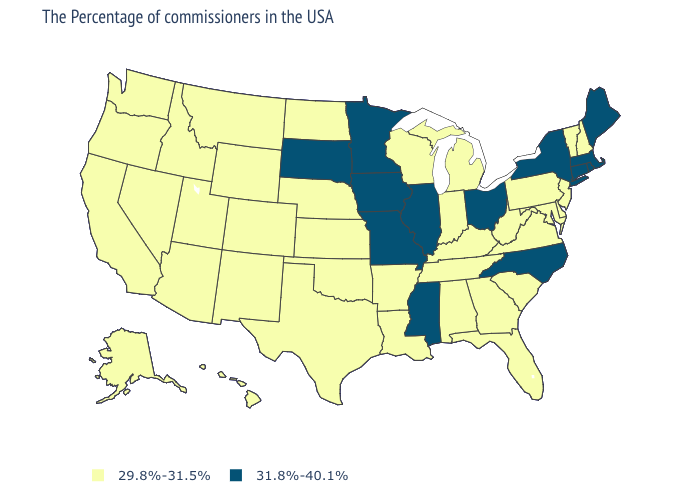Name the states that have a value in the range 31.8%-40.1%?
Write a very short answer. Maine, Massachusetts, Rhode Island, Connecticut, New York, North Carolina, Ohio, Illinois, Mississippi, Missouri, Minnesota, Iowa, South Dakota. Does the map have missing data?
Answer briefly. No. Name the states that have a value in the range 29.8%-31.5%?
Be succinct. New Hampshire, Vermont, New Jersey, Delaware, Maryland, Pennsylvania, Virginia, South Carolina, West Virginia, Florida, Georgia, Michigan, Kentucky, Indiana, Alabama, Tennessee, Wisconsin, Louisiana, Arkansas, Kansas, Nebraska, Oklahoma, Texas, North Dakota, Wyoming, Colorado, New Mexico, Utah, Montana, Arizona, Idaho, Nevada, California, Washington, Oregon, Alaska, Hawaii. Name the states that have a value in the range 29.8%-31.5%?
Be succinct. New Hampshire, Vermont, New Jersey, Delaware, Maryland, Pennsylvania, Virginia, South Carolina, West Virginia, Florida, Georgia, Michigan, Kentucky, Indiana, Alabama, Tennessee, Wisconsin, Louisiana, Arkansas, Kansas, Nebraska, Oklahoma, Texas, North Dakota, Wyoming, Colorado, New Mexico, Utah, Montana, Arizona, Idaho, Nevada, California, Washington, Oregon, Alaska, Hawaii. What is the highest value in the USA?
Concise answer only. 31.8%-40.1%. Name the states that have a value in the range 29.8%-31.5%?
Quick response, please. New Hampshire, Vermont, New Jersey, Delaware, Maryland, Pennsylvania, Virginia, South Carolina, West Virginia, Florida, Georgia, Michigan, Kentucky, Indiana, Alabama, Tennessee, Wisconsin, Louisiana, Arkansas, Kansas, Nebraska, Oklahoma, Texas, North Dakota, Wyoming, Colorado, New Mexico, Utah, Montana, Arizona, Idaho, Nevada, California, Washington, Oregon, Alaska, Hawaii. Does Nebraska have a higher value than Rhode Island?
Quick response, please. No. Name the states that have a value in the range 31.8%-40.1%?
Keep it brief. Maine, Massachusetts, Rhode Island, Connecticut, New York, North Carolina, Ohio, Illinois, Mississippi, Missouri, Minnesota, Iowa, South Dakota. Name the states that have a value in the range 31.8%-40.1%?
Keep it brief. Maine, Massachusetts, Rhode Island, Connecticut, New York, North Carolina, Ohio, Illinois, Mississippi, Missouri, Minnesota, Iowa, South Dakota. What is the lowest value in the USA?
Quick response, please. 29.8%-31.5%. Does Alabama have the same value as Washington?
Concise answer only. Yes. Which states have the lowest value in the USA?
Short answer required. New Hampshire, Vermont, New Jersey, Delaware, Maryland, Pennsylvania, Virginia, South Carolina, West Virginia, Florida, Georgia, Michigan, Kentucky, Indiana, Alabama, Tennessee, Wisconsin, Louisiana, Arkansas, Kansas, Nebraska, Oklahoma, Texas, North Dakota, Wyoming, Colorado, New Mexico, Utah, Montana, Arizona, Idaho, Nevada, California, Washington, Oregon, Alaska, Hawaii. 